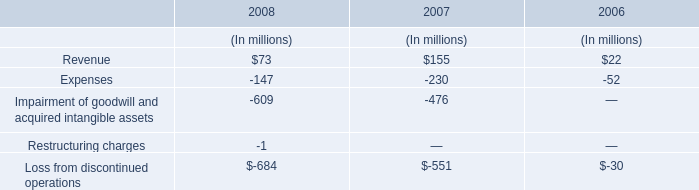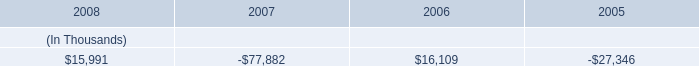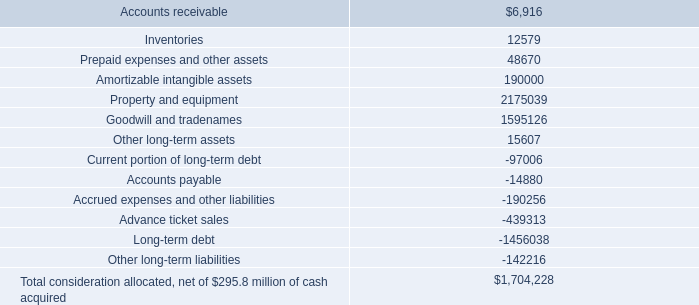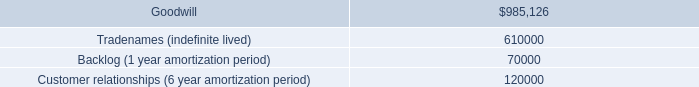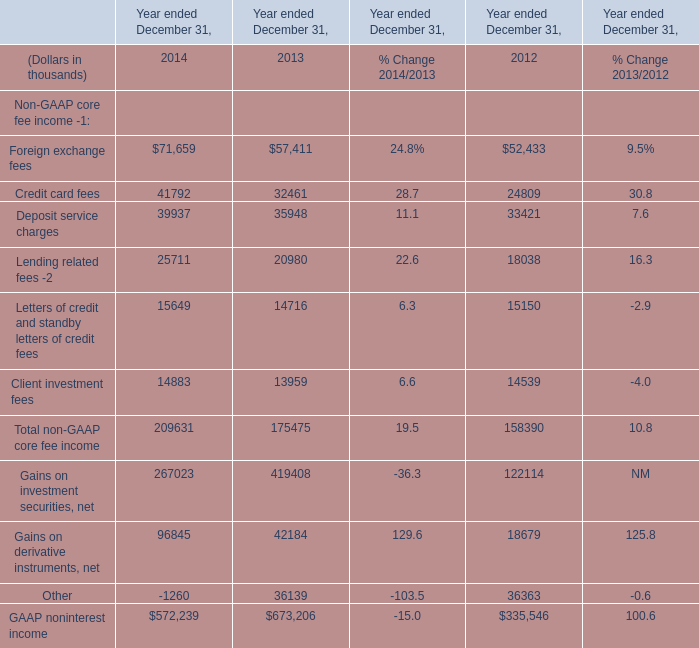what is the annual interest expense related to the series first mortgage bonds due august 2013 , in millions? 
Computations: (300 * 5.40%)
Answer: 16.2. 